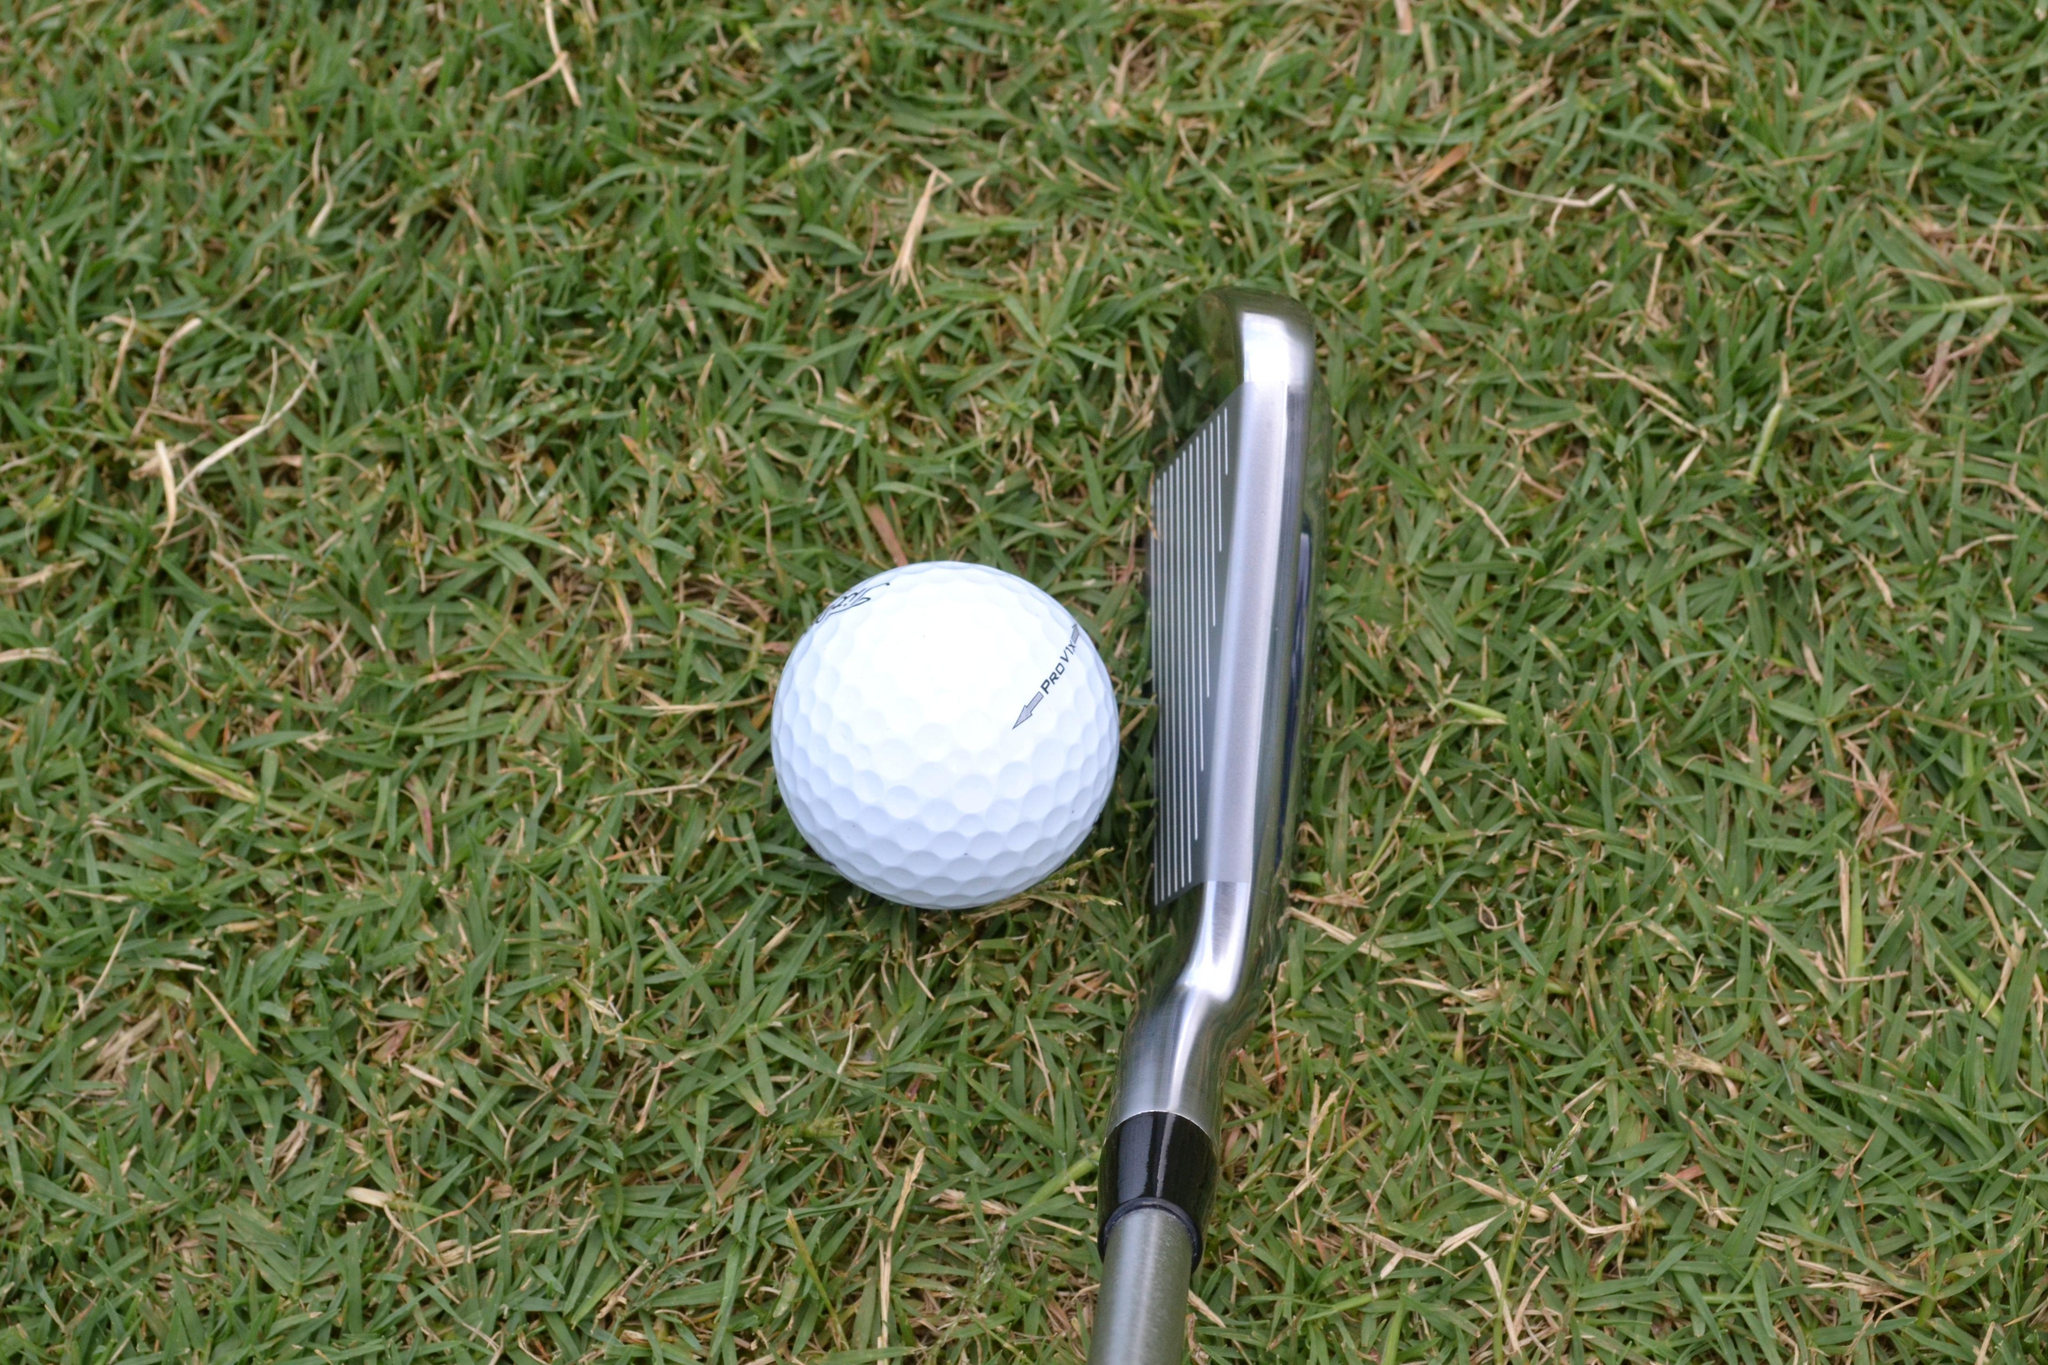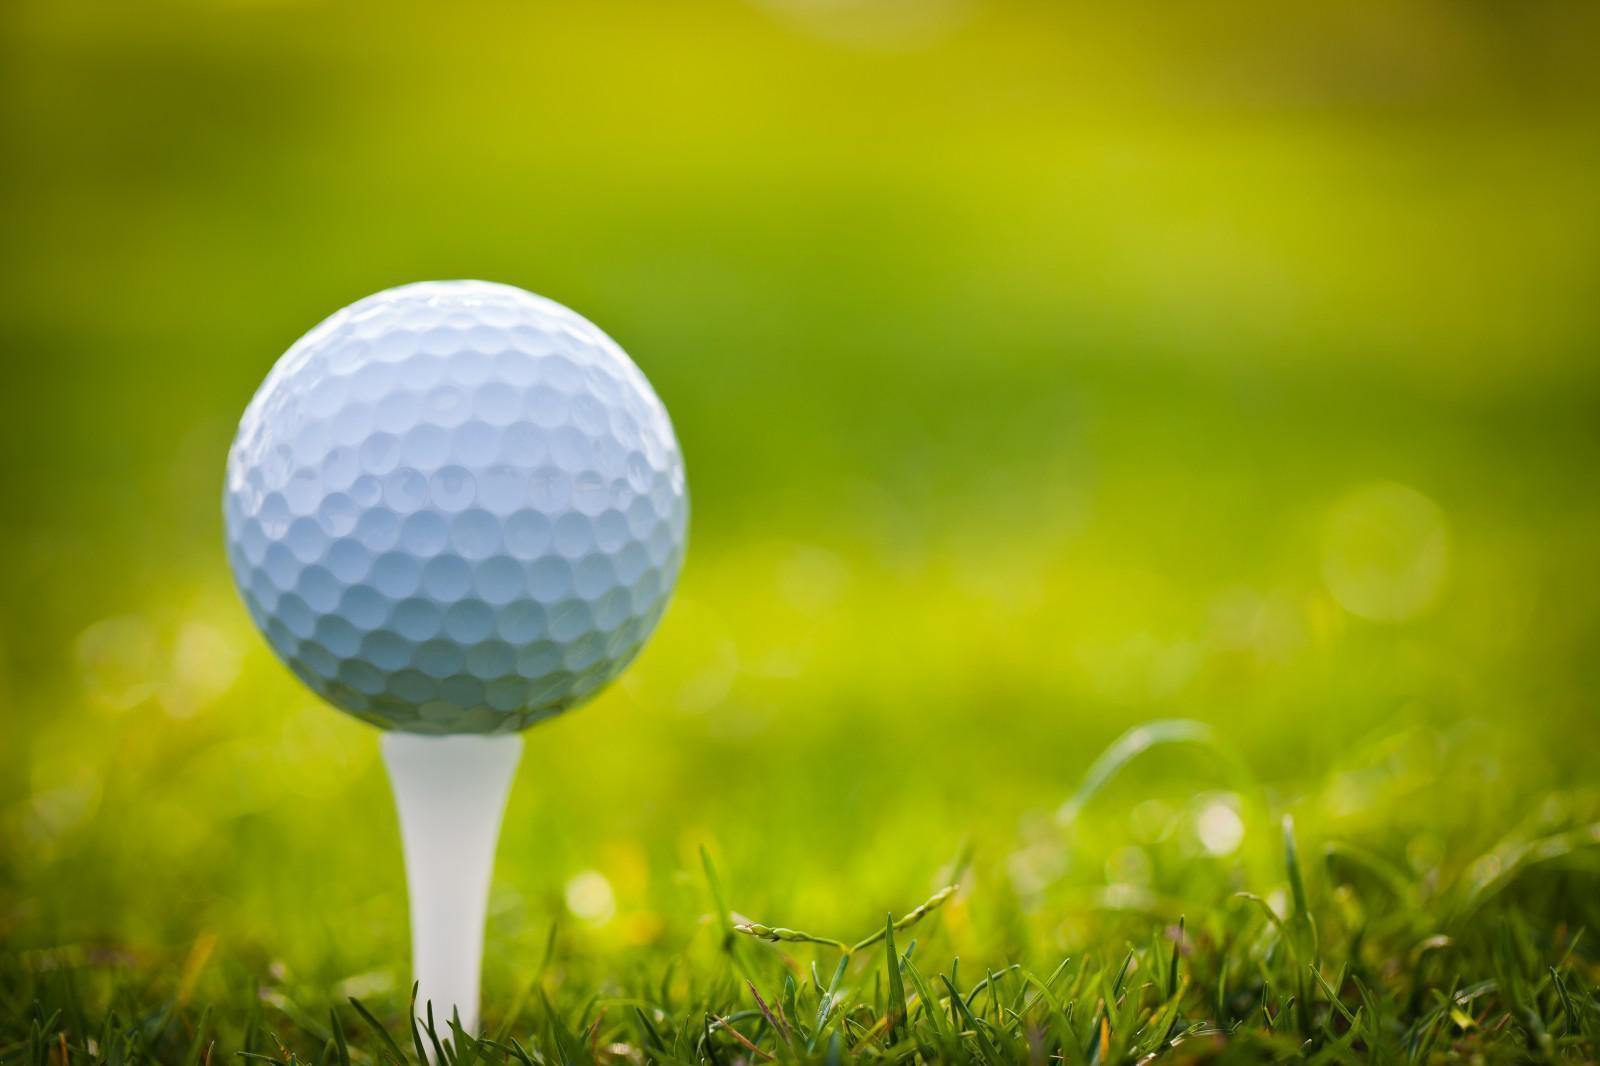The first image is the image on the left, the second image is the image on the right. Given the left and right images, does the statement "One of the images shows a golf ball on the grass." hold true? Answer yes or no. Yes. 